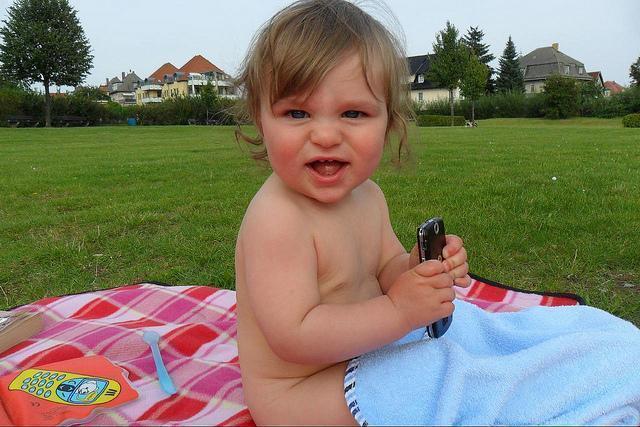What fairly important item is missing from this child?
Answer the question by selecting the correct answer among the 4 following choices.
Options: Bolo tie, diaper, jeans, wrist bands. Diaper. 